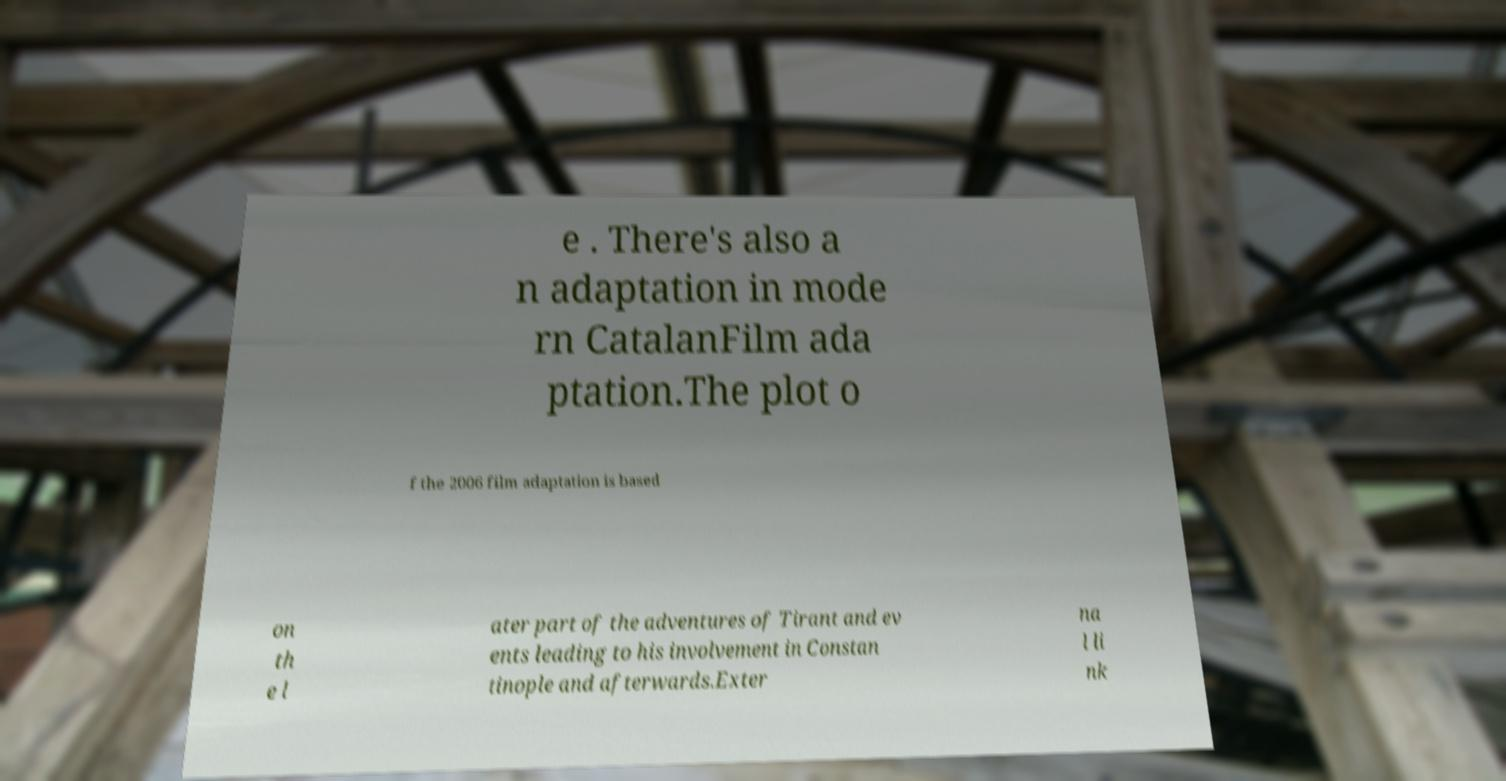Could you extract and type out the text from this image? e . There's also a n adaptation in mode rn CatalanFilm ada ptation.The plot o f the 2006 film adaptation is based on th e l ater part of the adventures of Tirant and ev ents leading to his involvement in Constan tinople and afterwards.Exter na l li nk 